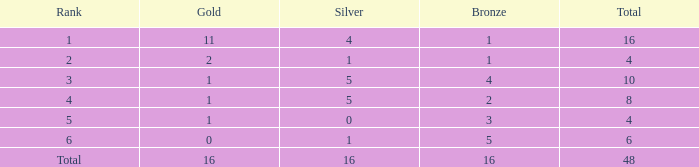How many gold are a rank 1 and larger than 16? 0.0. 